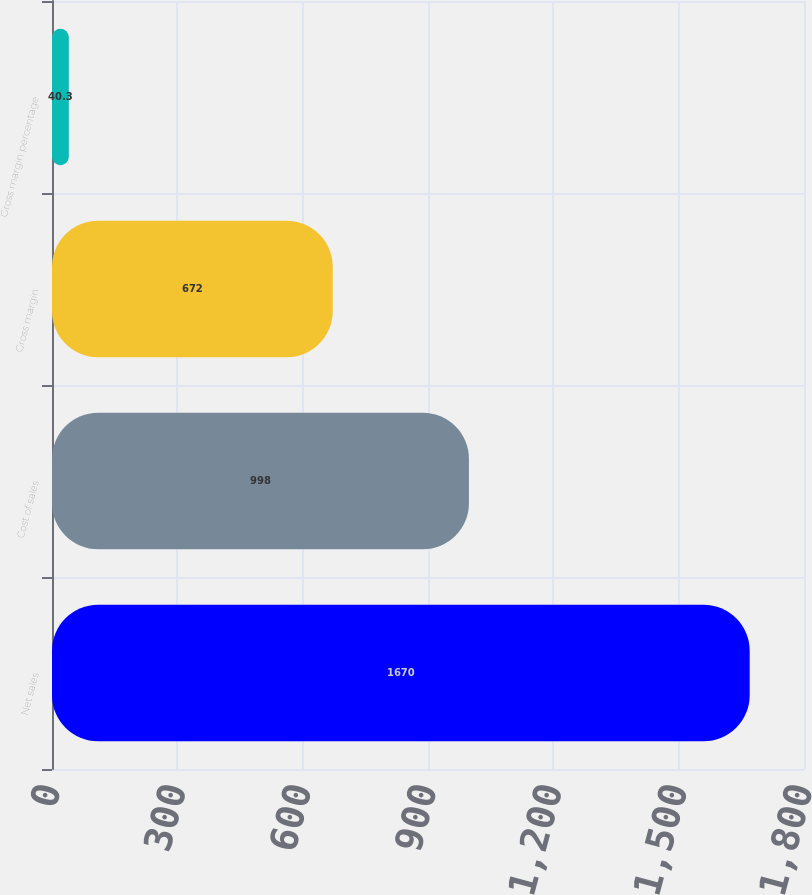<chart> <loc_0><loc_0><loc_500><loc_500><bar_chart><fcel>Net sales<fcel>Cost of sales<fcel>Gross margin<fcel>Gross margin percentage<nl><fcel>1670<fcel>998<fcel>672<fcel>40.3<nl></chart> 